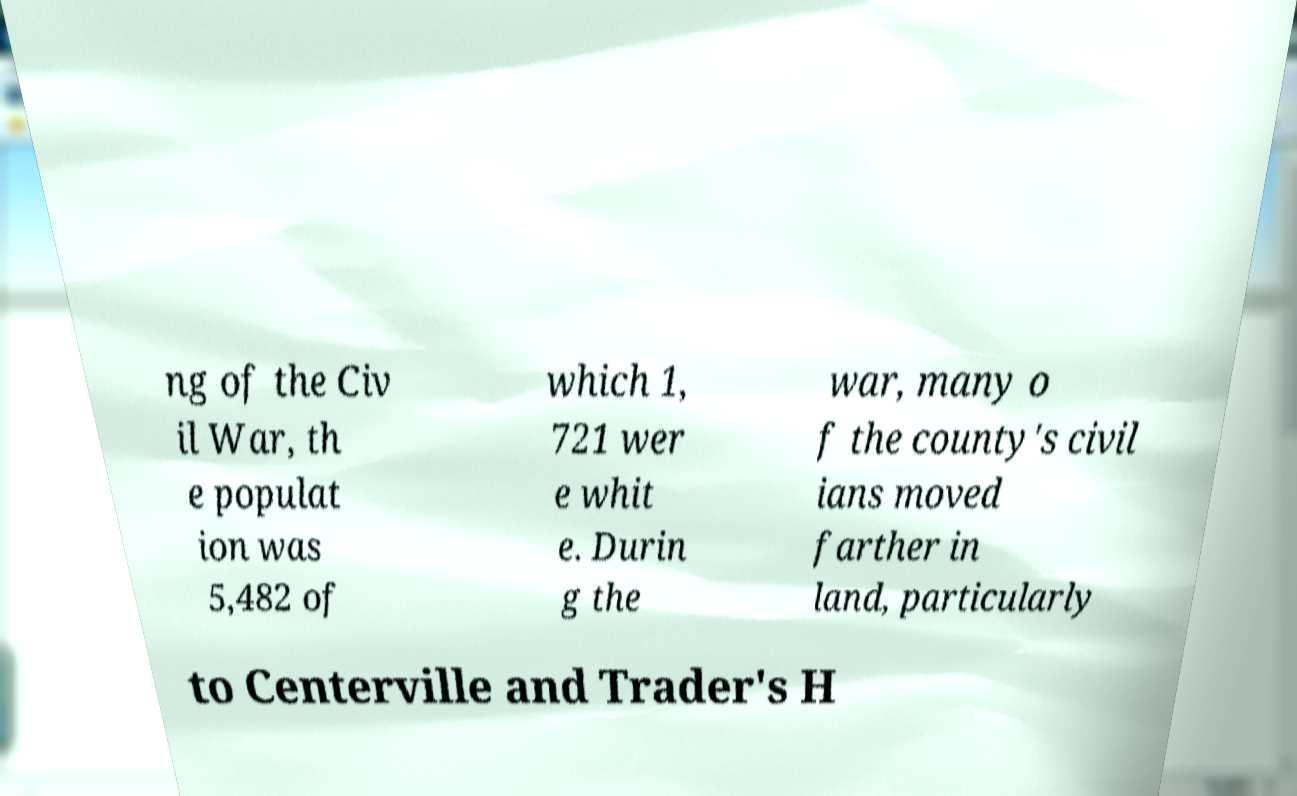There's text embedded in this image that I need extracted. Can you transcribe it verbatim? ng of the Civ il War, th e populat ion was 5,482 of which 1, 721 wer e whit e. Durin g the war, many o f the county's civil ians moved farther in land, particularly to Centerville and Trader's H 